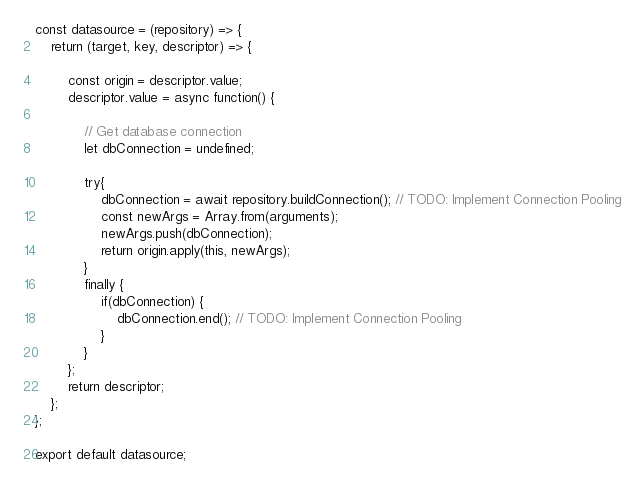Convert code to text. <code><loc_0><loc_0><loc_500><loc_500><_JavaScript_>const datasource = (repository) => {
    return (target, key, descriptor) => {
        
        const origin = descriptor.value;
        descriptor.value = async function() {

            // Get database connection
            let dbConnection = undefined;

            try{
                dbConnection = await repository.buildConnection(); // TODO: Implement Connection Pooling
                const newArgs = Array.from(arguments);
                newArgs.push(dbConnection);
                return origin.apply(this, newArgs);
            }
            finally {
                if(dbConnection) {
                    dbConnection.end(); // TODO: Implement Connection Pooling
                }
            }
        };
        return descriptor;
    };
};

export default datasource;</code> 